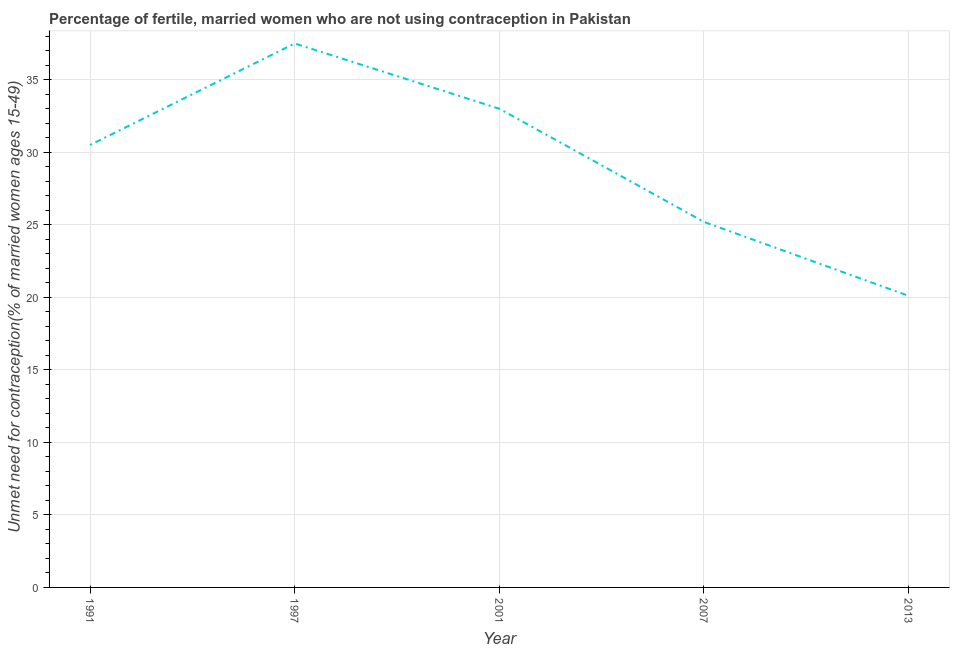What is the number of married women who are not using contraception in 2007?
Keep it short and to the point. 25.2. Across all years, what is the maximum number of married women who are not using contraception?
Make the answer very short. 37.5. Across all years, what is the minimum number of married women who are not using contraception?
Your response must be concise. 20.1. In which year was the number of married women who are not using contraception minimum?
Your answer should be compact. 2013. What is the sum of the number of married women who are not using contraception?
Your answer should be compact. 146.3. What is the difference between the number of married women who are not using contraception in 1991 and 1997?
Your answer should be very brief. -7. What is the average number of married women who are not using contraception per year?
Keep it short and to the point. 29.26. What is the median number of married women who are not using contraception?
Keep it short and to the point. 30.5. Do a majority of the years between 2007 and 1991 (inclusive) have number of married women who are not using contraception greater than 14 %?
Make the answer very short. Yes. What is the ratio of the number of married women who are not using contraception in 2007 to that in 2013?
Your answer should be very brief. 1.25. Is the number of married women who are not using contraception in 2001 less than that in 2007?
Offer a terse response. No. Is the difference between the number of married women who are not using contraception in 1997 and 2001 greater than the difference between any two years?
Provide a succinct answer. No. What is the difference between the highest and the second highest number of married women who are not using contraception?
Your answer should be compact. 4.5. What is the difference between the highest and the lowest number of married women who are not using contraception?
Offer a very short reply. 17.4. Does the number of married women who are not using contraception monotonically increase over the years?
Give a very brief answer. No. Are the values on the major ticks of Y-axis written in scientific E-notation?
Offer a very short reply. No. Does the graph contain any zero values?
Offer a terse response. No. What is the title of the graph?
Make the answer very short. Percentage of fertile, married women who are not using contraception in Pakistan. What is the label or title of the X-axis?
Offer a terse response. Year. What is the label or title of the Y-axis?
Provide a succinct answer.  Unmet need for contraception(% of married women ages 15-49). What is the  Unmet need for contraception(% of married women ages 15-49) of 1991?
Provide a succinct answer. 30.5. What is the  Unmet need for contraception(% of married women ages 15-49) in 1997?
Provide a succinct answer. 37.5. What is the  Unmet need for contraception(% of married women ages 15-49) of 2001?
Your answer should be very brief. 33. What is the  Unmet need for contraception(% of married women ages 15-49) of 2007?
Make the answer very short. 25.2. What is the  Unmet need for contraception(% of married women ages 15-49) of 2013?
Offer a terse response. 20.1. What is the difference between the  Unmet need for contraception(% of married women ages 15-49) in 1991 and 1997?
Make the answer very short. -7. What is the difference between the  Unmet need for contraception(% of married women ages 15-49) in 1991 and 2001?
Make the answer very short. -2.5. What is the difference between the  Unmet need for contraception(% of married women ages 15-49) in 1991 and 2007?
Provide a short and direct response. 5.3. What is the difference between the  Unmet need for contraception(% of married women ages 15-49) in 1997 and 2001?
Give a very brief answer. 4.5. What is the difference between the  Unmet need for contraception(% of married women ages 15-49) in 2001 and 2007?
Make the answer very short. 7.8. What is the difference between the  Unmet need for contraception(% of married women ages 15-49) in 2001 and 2013?
Offer a terse response. 12.9. What is the ratio of the  Unmet need for contraception(% of married women ages 15-49) in 1991 to that in 1997?
Ensure brevity in your answer.  0.81. What is the ratio of the  Unmet need for contraception(% of married women ages 15-49) in 1991 to that in 2001?
Your response must be concise. 0.92. What is the ratio of the  Unmet need for contraception(% of married women ages 15-49) in 1991 to that in 2007?
Provide a short and direct response. 1.21. What is the ratio of the  Unmet need for contraception(% of married women ages 15-49) in 1991 to that in 2013?
Ensure brevity in your answer.  1.52. What is the ratio of the  Unmet need for contraception(% of married women ages 15-49) in 1997 to that in 2001?
Ensure brevity in your answer.  1.14. What is the ratio of the  Unmet need for contraception(% of married women ages 15-49) in 1997 to that in 2007?
Make the answer very short. 1.49. What is the ratio of the  Unmet need for contraception(% of married women ages 15-49) in 1997 to that in 2013?
Offer a very short reply. 1.87. What is the ratio of the  Unmet need for contraception(% of married women ages 15-49) in 2001 to that in 2007?
Make the answer very short. 1.31. What is the ratio of the  Unmet need for contraception(% of married women ages 15-49) in 2001 to that in 2013?
Make the answer very short. 1.64. What is the ratio of the  Unmet need for contraception(% of married women ages 15-49) in 2007 to that in 2013?
Keep it short and to the point. 1.25. 